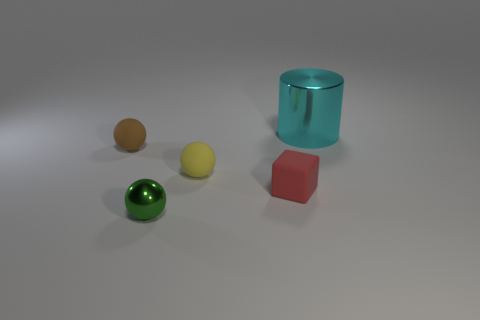There is a object that is behind the tiny yellow ball and in front of the cyan cylinder; what material is it?
Provide a short and direct response. Rubber. How many things are green matte objects or large metallic objects?
Provide a short and direct response. 1. Is the number of tiny brown balls greater than the number of small gray metallic balls?
Keep it short and to the point. Yes. What size is the metallic object that is right of the ball that is in front of the red thing?
Make the answer very short. Large. There is another small metallic thing that is the same shape as the small brown object; what color is it?
Your answer should be compact. Green. What size is the red block?
Provide a succinct answer. Small. How many cubes are cyan shiny things or red rubber objects?
Give a very brief answer. 1. There is another matte object that is the same shape as the tiny yellow object; what size is it?
Provide a succinct answer. Small. What number of tiny rubber blocks are there?
Your answer should be very brief. 1. There is a small yellow object; is it the same shape as the rubber object on the right side of the small yellow object?
Your answer should be compact. No. 